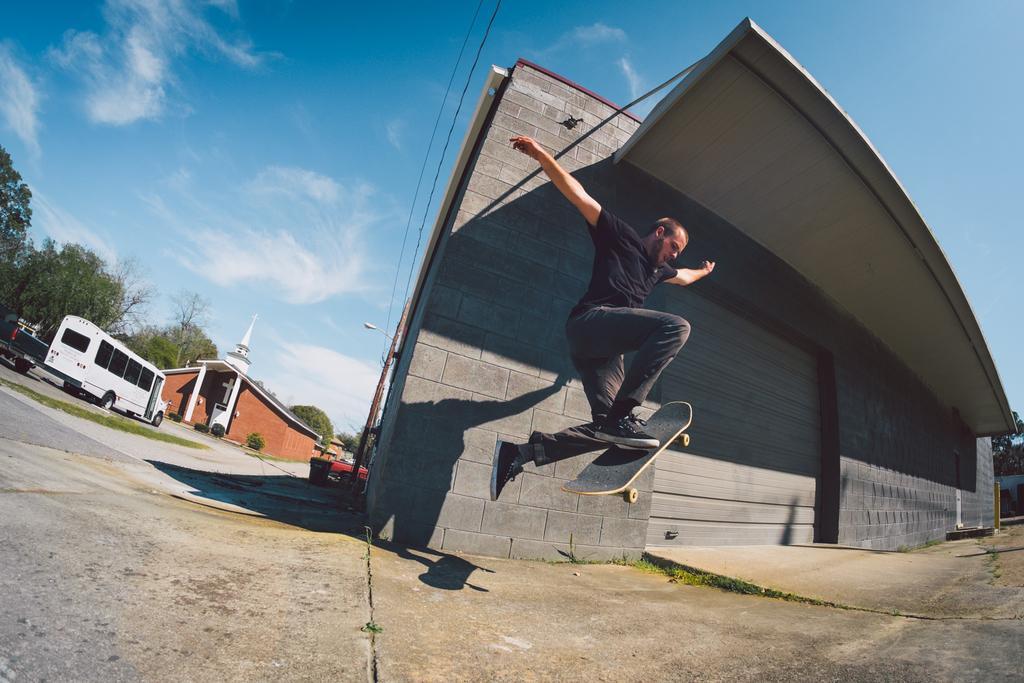How would you summarize this image in a sentence or two? In this image we can see a person on a skateboard. We can also see some buildings, poles, wires, a street pole, a trash bin, some vehicles on the road, grass, a group of trees and the sky which looks cloudy. 